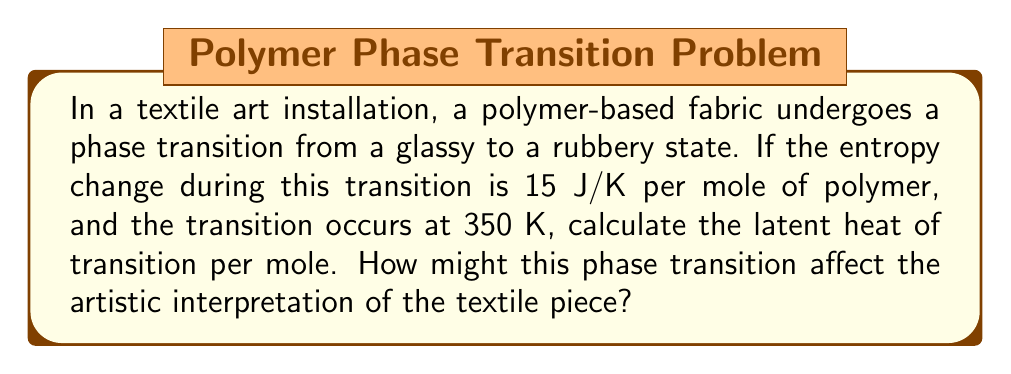Give your solution to this math problem. To solve this problem, we'll use the thermodynamic relationship between entropy, temperature, and latent heat at a phase transition. This relationship is given by the Clausius-Clapeyron equation in its simplified form:

$$\Delta S = \frac{L}{T}$$

Where:
$\Delta S$ is the change in entropy
$L$ is the latent heat of transition
$T$ is the temperature at which the transition occurs

Given:
$\Delta S = 15$ J/K per mole
$T = 350$ K

Step 1: Rearrange the equation to solve for $L$:
$$L = \Delta S \cdot T$$

Step 2: Substitute the known values:
$$L = 15 \text{ J/K} \cdot 350 \text{ K}$$

Step 3: Calculate the result:
$$L = 5250 \text{ J/mol} = 5.25 \text{ kJ/mol}$$

Artistic interpretation:
The phase transition from glassy to rubbery state involves a significant absorption of heat (5.25 kJ/mol). This transition could dramatically alter the texture, flexibility, and appearance of the textile art piece. As the material becomes more pliable, it may drape differently, potentially changing the entire visual composition. The artist might exploit this property to create dynamic installations that respond to temperature changes, challenging the viewer's perception of textile art as static and unchanging.
Answer: 5.25 kJ/mol 